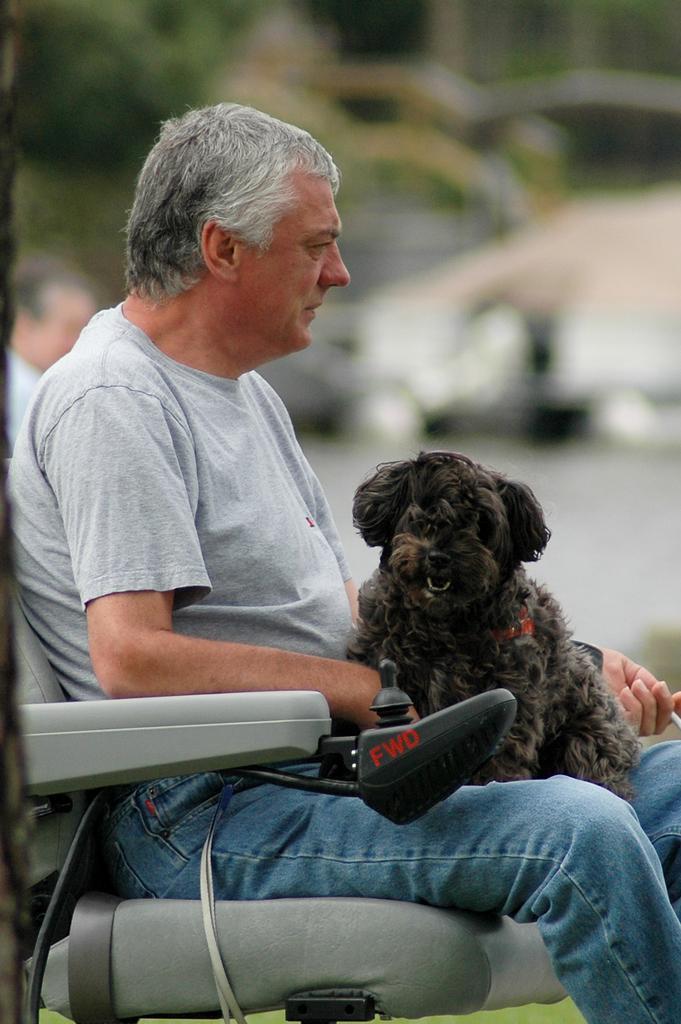Please provide a concise description of this image. Here we can see a old man sitting on a chair with a dog in his lap 